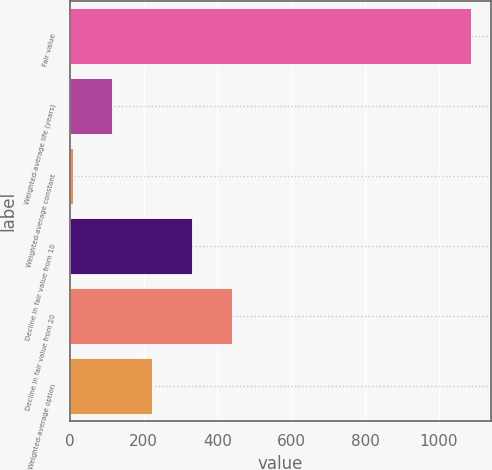Convert chart. <chart><loc_0><loc_0><loc_500><loc_500><bar_chart><fcel>Fair value<fcel>Weighted-average life (years)<fcel>Weighted-average constant<fcel>Decline in fair value from 10<fcel>Decline in fair value from 20<fcel>Weighted-average option<nl><fcel>1087<fcel>115.55<fcel>7.61<fcel>331.43<fcel>439.37<fcel>223.49<nl></chart> 